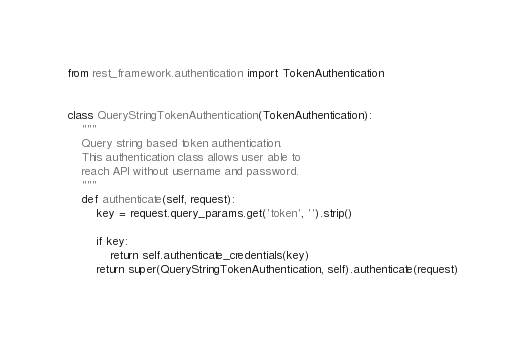Convert code to text. <code><loc_0><loc_0><loc_500><loc_500><_Python_>from rest_framework.authentication import TokenAuthentication


class QueryStringTokenAuthentication(TokenAuthentication):
    """
    Query string based token authentication.
    This authentication class allows user able to
    reach API without username and password.
    """
    def authenticate(self, request):
        key = request.query_params.get('token', '').strip()

        if key:
            return self.authenticate_credentials(key)
        return super(QueryStringTokenAuthentication, self).authenticate(request)
</code> 